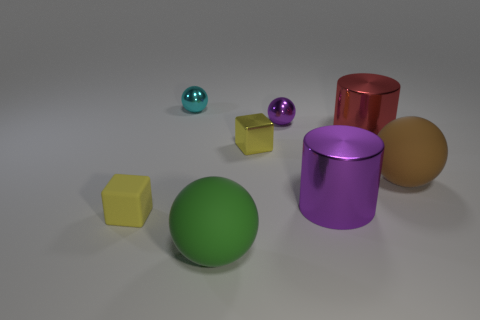Do the tiny matte object and the small shiny block have the same color?
Keep it short and to the point. Yes. How many objects are small brown matte cylinders or tiny spheres that are in front of the small cyan metal thing?
Keep it short and to the point. 1. Is there a red cylinder of the same size as the cyan shiny sphere?
Your answer should be compact. No. Does the green thing have the same material as the purple cylinder?
Offer a very short reply. No. What number of things are tiny purple spheres or large rubber balls?
Your response must be concise. 3. What is the size of the purple metallic cylinder?
Offer a terse response. Large. Are there fewer purple objects than large cubes?
Give a very brief answer. No. What number of objects are the same color as the shiny cube?
Give a very brief answer. 1. There is a big thing to the right of the big red metallic object; does it have the same color as the tiny metallic cube?
Ensure brevity in your answer.  No. The small yellow thing that is left of the cyan object has what shape?
Provide a succinct answer. Cube. 